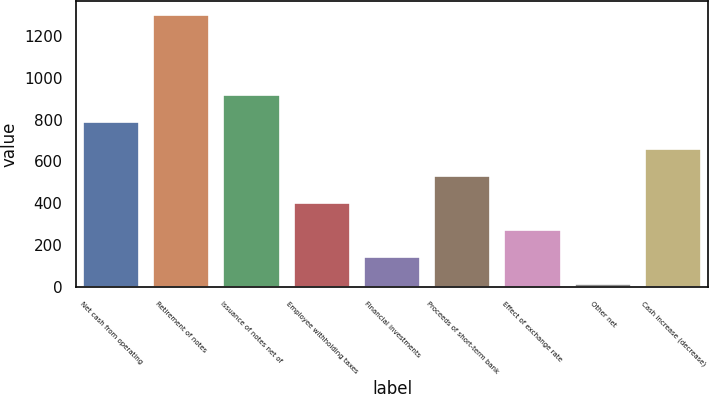<chart> <loc_0><loc_0><loc_500><loc_500><bar_chart><fcel>Net cash from operating<fcel>Retirement of notes<fcel>Issuance of notes net of<fcel>Employee withholding taxes<fcel>Financial investments<fcel>Proceeds of short-term bank<fcel>Effect of exchange rate<fcel>Other net<fcel>Cash increase (decrease)<nl><fcel>789<fcel>1300<fcel>917.5<fcel>400.5<fcel>143.5<fcel>529<fcel>272<fcel>15<fcel>657.5<nl></chart> 